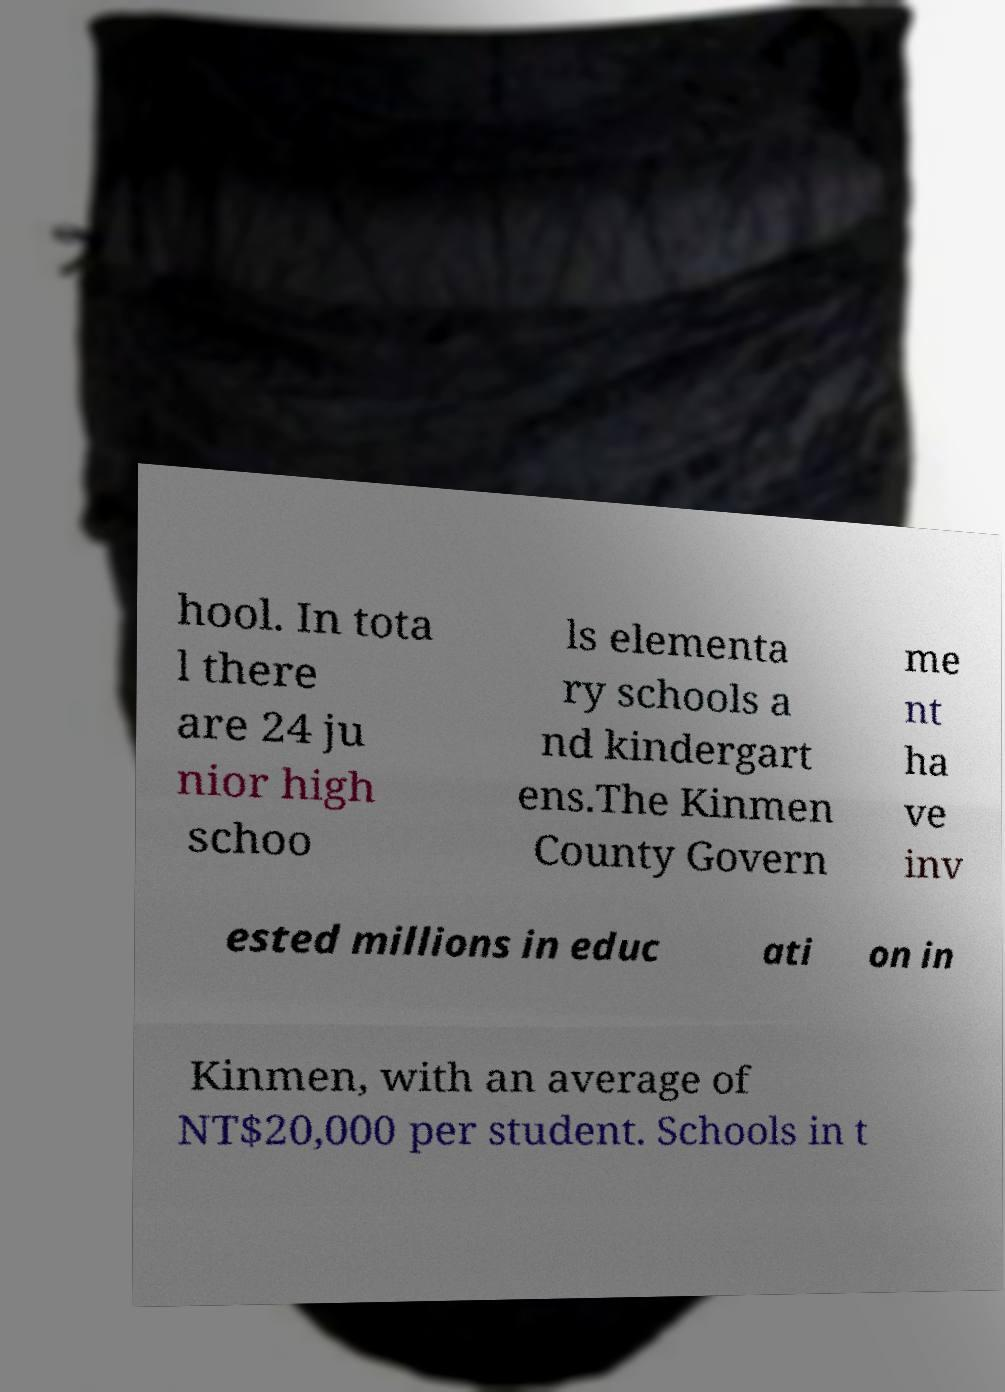I need the written content from this picture converted into text. Can you do that? hool. In tota l there are 24 ju nior high schoo ls elementa ry schools a nd kindergart ens.The Kinmen County Govern me nt ha ve inv ested millions in educ ati on in Kinmen, with an average of NT$20,000 per student. Schools in t 